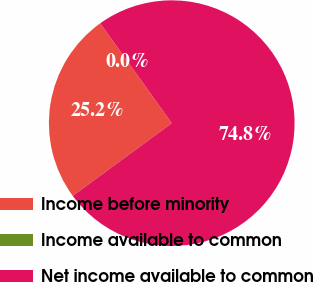Convert chart to OTSL. <chart><loc_0><loc_0><loc_500><loc_500><pie_chart><fcel>Income before minority<fcel>Income available to common<fcel>Net income available to common<nl><fcel>25.2%<fcel>0.0%<fcel>74.8%<nl></chart> 